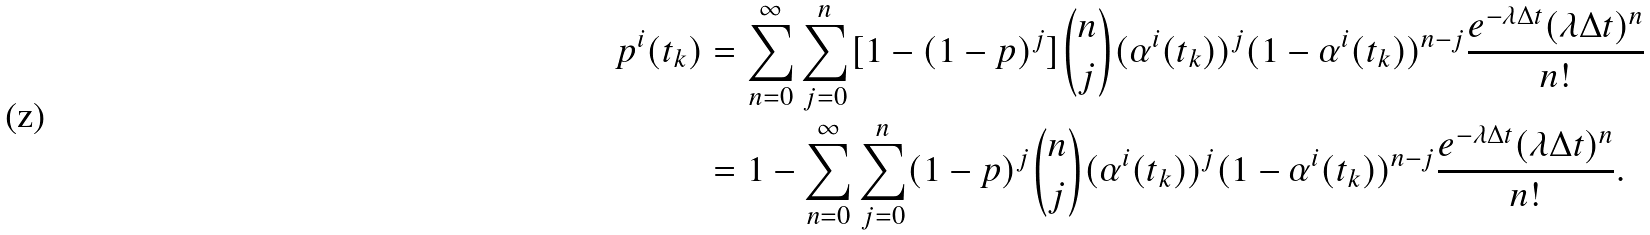<formula> <loc_0><loc_0><loc_500><loc_500>p ^ { i } ( t _ { k } ) & = \sum _ { n = 0 } ^ { \infty } \sum _ { j = 0 } ^ { n } [ 1 - ( 1 - p ) ^ { j } ] \binom { n } { j } ( \alpha ^ { i } ( t _ { k } ) ) ^ { j } ( 1 - \alpha ^ { i } ( t _ { k } ) ) ^ { n - j } \frac { e ^ { - \lambda \Delta t } ( \lambda \Delta t ) ^ { n } } { n ! } \\ & = 1 - \sum _ { n = 0 } ^ { \infty } \sum _ { j = 0 } ^ { n } ( 1 - p ) ^ { j } \binom { n } { j } ( \alpha ^ { i } ( t _ { k } ) ) ^ { j } ( 1 - \alpha ^ { i } ( t _ { k } ) ) ^ { n - j } \frac { e ^ { - \lambda \Delta t } ( \lambda \Delta t ) ^ { n } } { n ! } .</formula> 